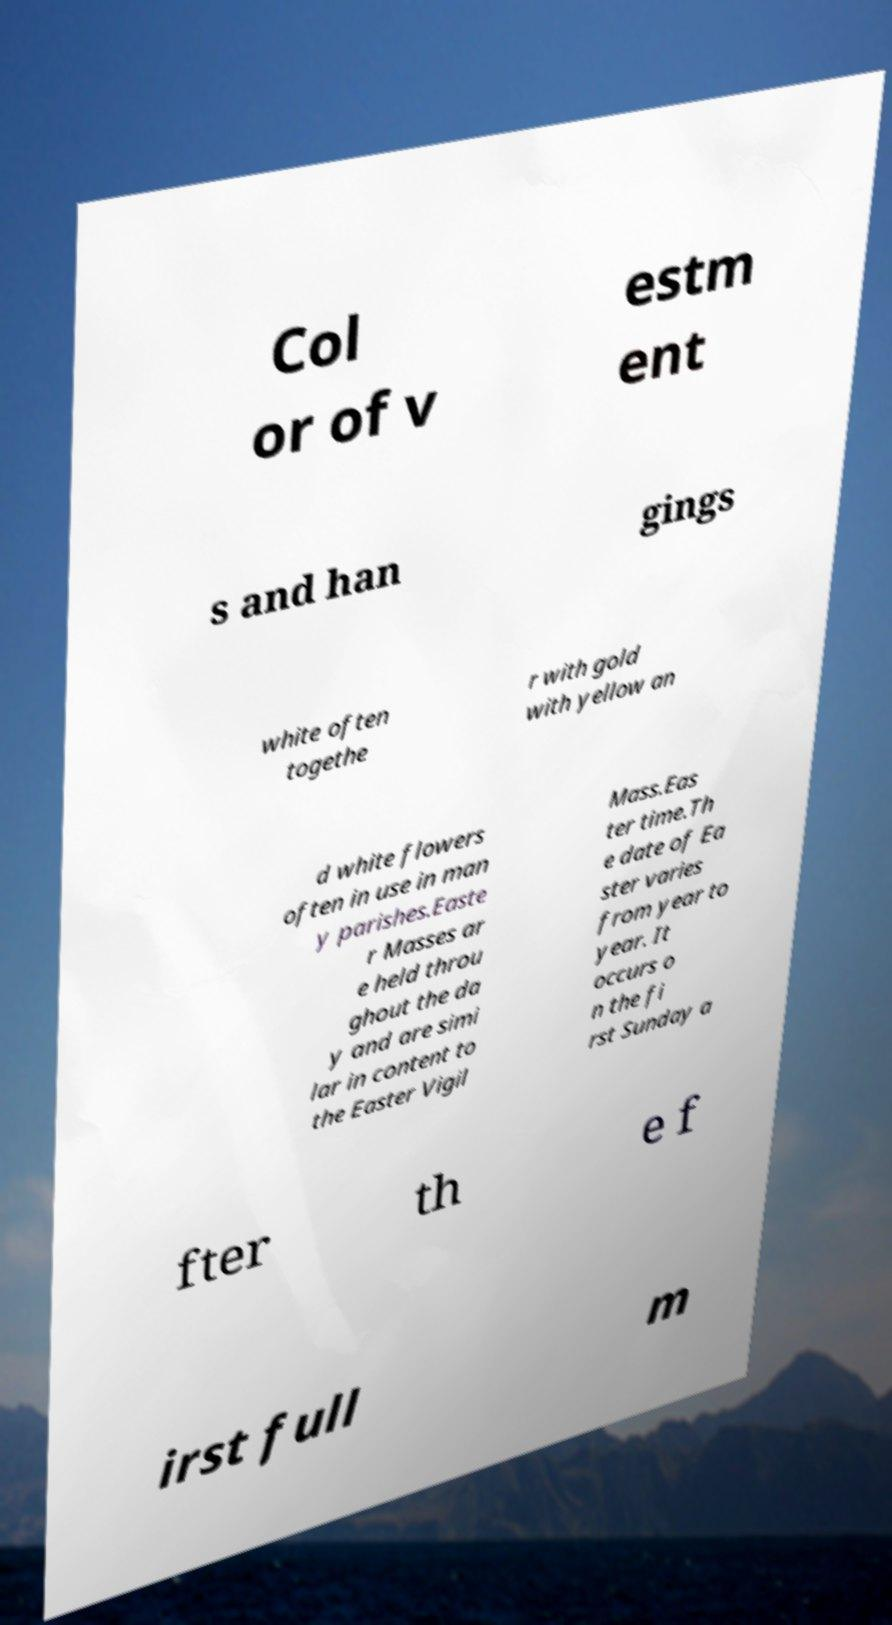Please identify and transcribe the text found in this image. Col or of v estm ent s and han gings white often togethe r with gold with yellow an d white flowers often in use in man y parishes.Easte r Masses ar e held throu ghout the da y and are simi lar in content to the Easter Vigil Mass.Eas ter time.Th e date of Ea ster varies from year to year. It occurs o n the fi rst Sunday a fter th e f irst full m 